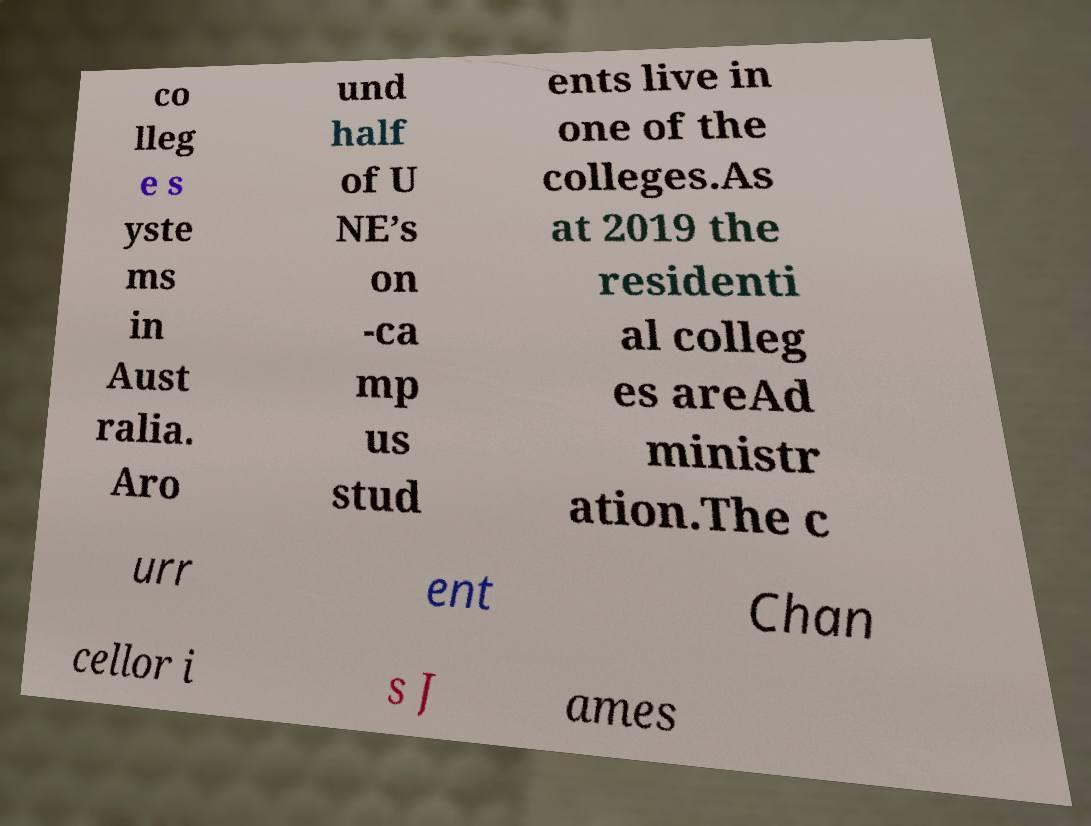Could you extract and type out the text from this image? co lleg e s yste ms in Aust ralia. Aro und half of U NE’s on -ca mp us stud ents live in one of the colleges.As at 2019 the residenti al colleg es areAd ministr ation.The c urr ent Chan cellor i s J ames 